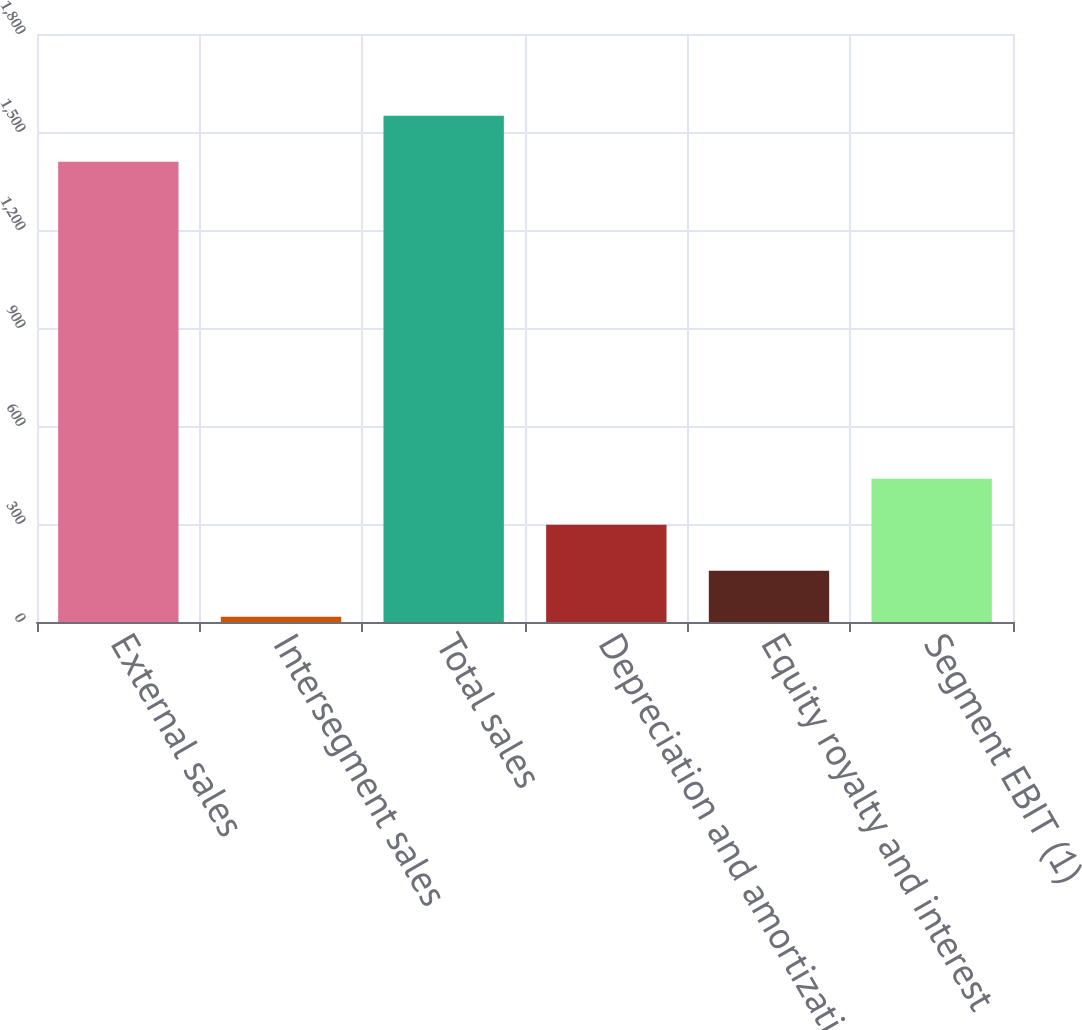Convert chart to OTSL. <chart><loc_0><loc_0><loc_500><loc_500><bar_chart><fcel>External sales<fcel>Intersegment sales<fcel>Total sales<fcel>Depreciation and amortization<fcel>Equity royalty and interest<fcel>Segment EBIT (1)<nl><fcel>1409<fcel>16<fcel>1549.9<fcel>297.8<fcel>156.9<fcel>438.7<nl></chart> 